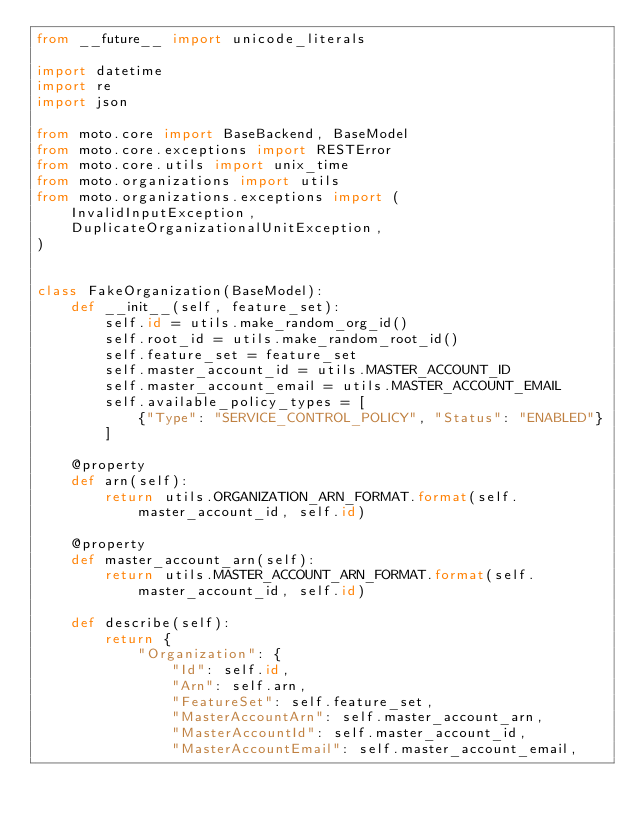<code> <loc_0><loc_0><loc_500><loc_500><_Python_>from __future__ import unicode_literals

import datetime
import re
import json

from moto.core import BaseBackend, BaseModel
from moto.core.exceptions import RESTError
from moto.core.utils import unix_time
from moto.organizations import utils
from moto.organizations.exceptions import (
    InvalidInputException,
    DuplicateOrganizationalUnitException,
)


class FakeOrganization(BaseModel):
    def __init__(self, feature_set):
        self.id = utils.make_random_org_id()
        self.root_id = utils.make_random_root_id()
        self.feature_set = feature_set
        self.master_account_id = utils.MASTER_ACCOUNT_ID
        self.master_account_email = utils.MASTER_ACCOUNT_EMAIL
        self.available_policy_types = [
            {"Type": "SERVICE_CONTROL_POLICY", "Status": "ENABLED"}
        ]

    @property
    def arn(self):
        return utils.ORGANIZATION_ARN_FORMAT.format(self.master_account_id, self.id)

    @property
    def master_account_arn(self):
        return utils.MASTER_ACCOUNT_ARN_FORMAT.format(self.master_account_id, self.id)

    def describe(self):
        return {
            "Organization": {
                "Id": self.id,
                "Arn": self.arn,
                "FeatureSet": self.feature_set,
                "MasterAccountArn": self.master_account_arn,
                "MasterAccountId": self.master_account_id,
                "MasterAccountEmail": self.master_account_email,</code> 